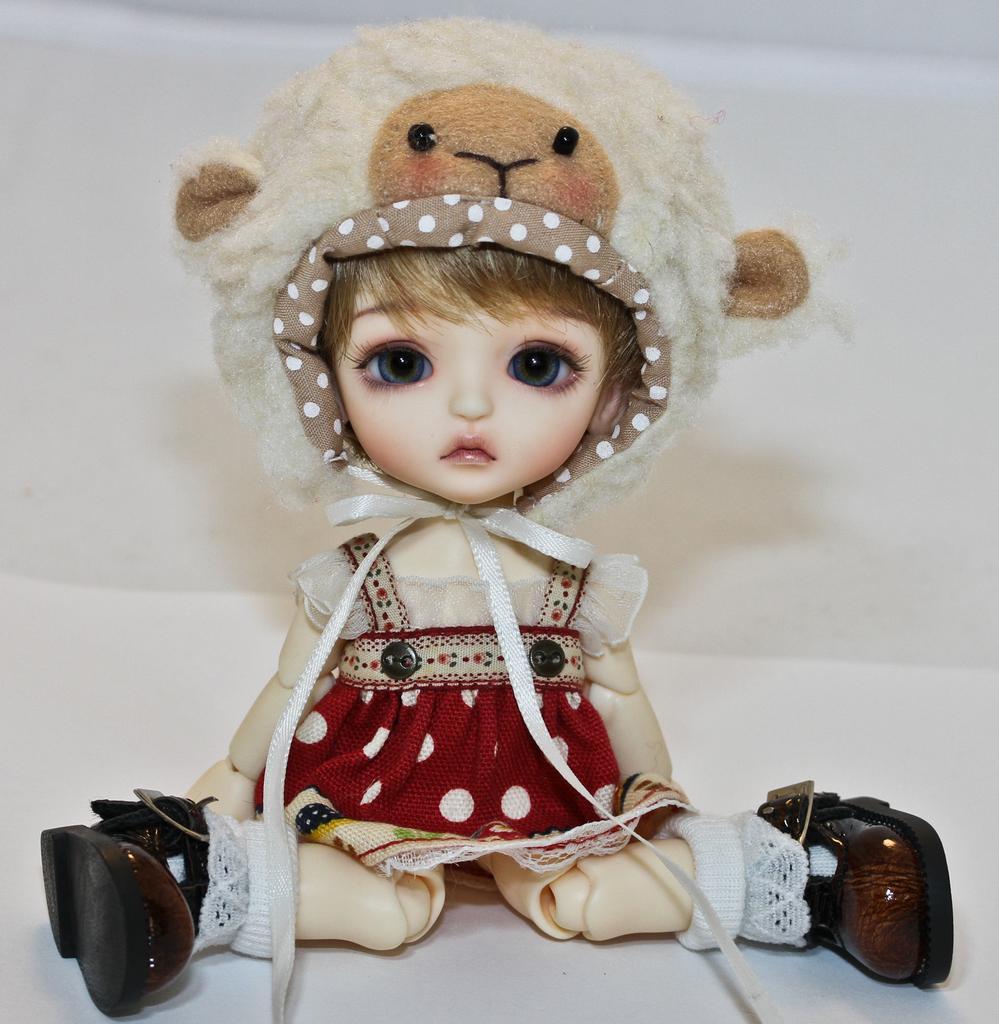Please provide a concise description of this image. In the image we can see a doll, wearing clothes, shoes and cap. The doll is sitting on the white surface and the wall. 